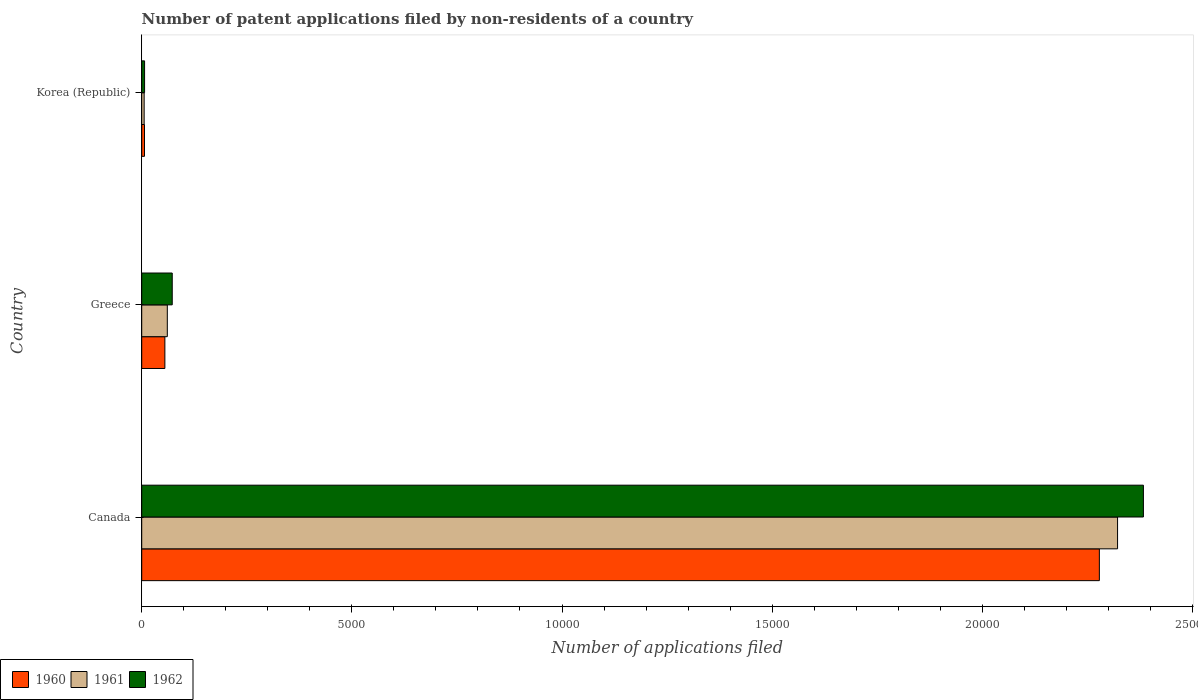Are the number of bars per tick equal to the number of legend labels?
Give a very brief answer. Yes. How many bars are there on the 2nd tick from the top?
Your response must be concise. 3. What is the label of the 3rd group of bars from the top?
Your answer should be very brief. Canada. What is the number of applications filed in 1960 in Korea (Republic)?
Your answer should be compact. 66. Across all countries, what is the maximum number of applications filed in 1960?
Keep it short and to the point. 2.28e+04. In which country was the number of applications filed in 1961 minimum?
Keep it short and to the point. Korea (Republic). What is the total number of applications filed in 1961 in the graph?
Your answer should be compact. 2.39e+04. What is the difference between the number of applications filed in 1962 in Greece and that in Korea (Republic)?
Your response must be concise. 658. What is the difference between the number of applications filed in 1961 in Canada and the number of applications filed in 1962 in Korea (Republic)?
Your response must be concise. 2.32e+04. What is the average number of applications filed in 1962 per country?
Offer a very short reply. 8209.33. What is the difference between the number of applications filed in 1960 and number of applications filed in 1962 in Korea (Republic)?
Ensure brevity in your answer.  -2. In how many countries, is the number of applications filed in 1960 greater than 11000 ?
Keep it short and to the point. 1. What is the ratio of the number of applications filed in 1960 in Greece to that in Korea (Republic)?
Keep it short and to the point. 8.35. Is the difference between the number of applications filed in 1960 in Canada and Greece greater than the difference between the number of applications filed in 1962 in Canada and Greece?
Offer a terse response. No. What is the difference between the highest and the second highest number of applications filed in 1960?
Your answer should be very brief. 2.22e+04. What is the difference between the highest and the lowest number of applications filed in 1962?
Offer a very short reply. 2.38e+04. What does the 3rd bar from the top in Greece represents?
Keep it short and to the point. 1960. What does the 2nd bar from the bottom in Greece represents?
Provide a short and direct response. 1961. Is it the case that in every country, the sum of the number of applications filed in 1960 and number of applications filed in 1961 is greater than the number of applications filed in 1962?
Offer a very short reply. Yes. How many bars are there?
Offer a very short reply. 9. Are all the bars in the graph horizontal?
Your answer should be compact. Yes. How many countries are there in the graph?
Give a very brief answer. 3. What is the difference between two consecutive major ticks on the X-axis?
Your answer should be compact. 5000. Does the graph contain any zero values?
Your answer should be very brief. No. Does the graph contain grids?
Your answer should be very brief. No. Where does the legend appear in the graph?
Make the answer very short. Bottom left. How many legend labels are there?
Give a very brief answer. 3. How are the legend labels stacked?
Provide a short and direct response. Horizontal. What is the title of the graph?
Ensure brevity in your answer.  Number of patent applications filed by non-residents of a country. Does "1984" appear as one of the legend labels in the graph?
Make the answer very short. No. What is the label or title of the X-axis?
Your response must be concise. Number of applications filed. What is the label or title of the Y-axis?
Offer a very short reply. Country. What is the Number of applications filed of 1960 in Canada?
Provide a short and direct response. 2.28e+04. What is the Number of applications filed in 1961 in Canada?
Make the answer very short. 2.32e+04. What is the Number of applications filed of 1962 in Canada?
Offer a very short reply. 2.38e+04. What is the Number of applications filed of 1960 in Greece?
Your answer should be compact. 551. What is the Number of applications filed in 1961 in Greece?
Make the answer very short. 609. What is the Number of applications filed in 1962 in Greece?
Ensure brevity in your answer.  726. What is the Number of applications filed in 1960 in Korea (Republic)?
Offer a very short reply. 66. What is the Number of applications filed of 1962 in Korea (Republic)?
Your answer should be compact. 68. Across all countries, what is the maximum Number of applications filed of 1960?
Offer a terse response. 2.28e+04. Across all countries, what is the maximum Number of applications filed in 1961?
Keep it short and to the point. 2.32e+04. Across all countries, what is the maximum Number of applications filed in 1962?
Ensure brevity in your answer.  2.38e+04. Across all countries, what is the minimum Number of applications filed of 1960?
Your answer should be very brief. 66. Across all countries, what is the minimum Number of applications filed of 1962?
Offer a terse response. 68. What is the total Number of applications filed of 1960 in the graph?
Provide a short and direct response. 2.34e+04. What is the total Number of applications filed of 1961 in the graph?
Provide a succinct answer. 2.39e+04. What is the total Number of applications filed in 1962 in the graph?
Keep it short and to the point. 2.46e+04. What is the difference between the Number of applications filed of 1960 in Canada and that in Greece?
Ensure brevity in your answer.  2.22e+04. What is the difference between the Number of applications filed of 1961 in Canada and that in Greece?
Your answer should be very brief. 2.26e+04. What is the difference between the Number of applications filed in 1962 in Canada and that in Greece?
Your response must be concise. 2.31e+04. What is the difference between the Number of applications filed in 1960 in Canada and that in Korea (Republic)?
Make the answer very short. 2.27e+04. What is the difference between the Number of applications filed of 1961 in Canada and that in Korea (Republic)?
Make the answer very short. 2.32e+04. What is the difference between the Number of applications filed of 1962 in Canada and that in Korea (Republic)?
Offer a terse response. 2.38e+04. What is the difference between the Number of applications filed in 1960 in Greece and that in Korea (Republic)?
Provide a succinct answer. 485. What is the difference between the Number of applications filed of 1961 in Greece and that in Korea (Republic)?
Give a very brief answer. 551. What is the difference between the Number of applications filed in 1962 in Greece and that in Korea (Republic)?
Keep it short and to the point. 658. What is the difference between the Number of applications filed in 1960 in Canada and the Number of applications filed in 1961 in Greece?
Offer a very short reply. 2.22e+04. What is the difference between the Number of applications filed in 1960 in Canada and the Number of applications filed in 1962 in Greece?
Your answer should be compact. 2.21e+04. What is the difference between the Number of applications filed in 1961 in Canada and the Number of applications filed in 1962 in Greece?
Make the answer very short. 2.25e+04. What is the difference between the Number of applications filed of 1960 in Canada and the Number of applications filed of 1961 in Korea (Republic)?
Ensure brevity in your answer.  2.27e+04. What is the difference between the Number of applications filed of 1960 in Canada and the Number of applications filed of 1962 in Korea (Republic)?
Your answer should be compact. 2.27e+04. What is the difference between the Number of applications filed in 1961 in Canada and the Number of applications filed in 1962 in Korea (Republic)?
Your response must be concise. 2.32e+04. What is the difference between the Number of applications filed in 1960 in Greece and the Number of applications filed in 1961 in Korea (Republic)?
Your answer should be compact. 493. What is the difference between the Number of applications filed of 1960 in Greece and the Number of applications filed of 1962 in Korea (Republic)?
Offer a terse response. 483. What is the difference between the Number of applications filed in 1961 in Greece and the Number of applications filed in 1962 in Korea (Republic)?
Give a very brief answer. 541. What is the average Number of applications filed in 1960 per country?
Keep it short and to the point. 7801. What is the average Number of applications filed of 1961 per country?
Your answer should be very brief. 7962. What is the average Number of applications filed in 1962 per country?
Make the answer very short. 8209.33. What is the difference between the Number of applications filed in 1960 and Number of applications filed in 1961 in Canada?
Provide a succinct answer. -433. What is the difference between the Number of applications filed in 1960 and Number of applications filed in 1962 in Canada?
Offer a very short reply. -1048. What is the difference between the Number of applications filed in 1961 and Number of applications filed in 1962 in Canada?
Provide a succinct answer. -615. What is the difference between the Number of applications filed of 1960 and Number of applications filed of 1961 in Greece?
Make the answer very short. -58. What is the difference between the Number of applications filed in 1960 and Number of applications filed in 1962 in Greece?
Keep it short and to the point. -175. What is the difference between the Number of applications filed of 1961 and Number of applications filed of 1962 in Greece?
Offer a very short reply. -117. What is the ratio of the Number of applications filed in 1960 in Canada to that in Greece?
Your answer should be very brief. 41.35. What is the ratio of the Number of applications filed in 1961 in Canada to that in Greece?
Give a very brief answer. 38.13. What is the ratio of the Number of applications filed of 1962 in Canada to that in Greece?
Make the answer very short. 32.83. What is the ratio of the Number of applications filed of 1960 in Canada to that in Korea (Republic)?
Make the answer very short. 345.24. What is the ratio of the Number of applications filed in 1961 in Canada to that in Korea (Republic)?
Provide a succinct answer. 400.33. What is the ratio of the Number of applications filed of 1962 in Canada to that in Korea (Republic)?
Provide a short and direct response. 350.5. What is the ratio of the Number of applications filed of 1960 in Greece to that in Korea (Republic)?
Give a very brief answer. 8.35. What is the ratio of the Number of applications filed in 1961 in Greece to that in Korea (Republic)?
Offer a terse response. 10.5. What is the ratio of the Number of applications filed of 1962 in Greece to that in Korea (Republic)?
Your answer should be very brief. 10.68. What is the difference between the highest and the second highest Number of applications filed in 1960?
Provide a short and direct response. 2.22e+04. What is the difference between the highest and the second highest Number of applications filed in 1961?
Offer a terse response. 2.26e+04. What is the difference between the highest and the second highest Number of applications filed of 1962?
Make the answer very short. 2.31e+04. What is the difference between the highest and the lowest Number of applications filed of 1960?
Offer a very short reply. 2.27e+04. What is the difference between the highest and the lowest Number of applications filed in 1961?
Keep it short and to the point. 2.32e+04. What is the difference between the highest and the lowest Number of applications filed of 1962?
Your answer should be compact. 2.38e+04. 